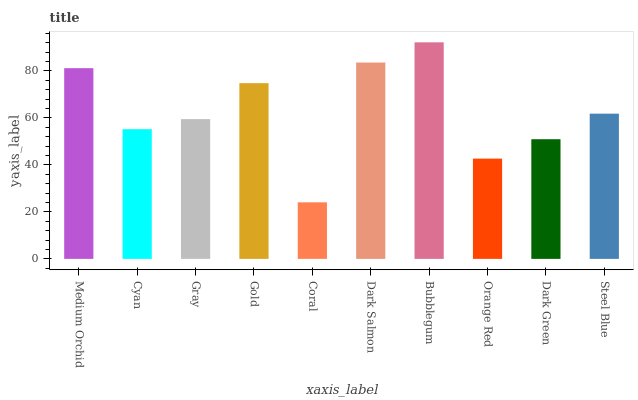Is Coral the minimum?
Answer yes or no. Yes. Is Bubblegum the maximum?
Answer yes or no. Yes. Is Cyan the minimum?
Answer yes or no. No. Is Cyan the maximum?
Answer yes or no. No. Is Medium Orchid greater than Cyan?
Answer yes or no. Yes. Is Cyan less than Medium Orchid?
Answer yes or no. Yes. Is Cyan greater than Medium Orchid?
Answer yes or no. No. Is Medium Orchid less than Cyan?
Answer yes or no. No. Is Steel Blue the high median?
Answer yes or no. Yes. Is Gray the low median?
Answer yes or no. Yes. Is Gold the high median?
Answer yes or no. No. Is Steel Blue the low median?
Answer yes or no. No. 